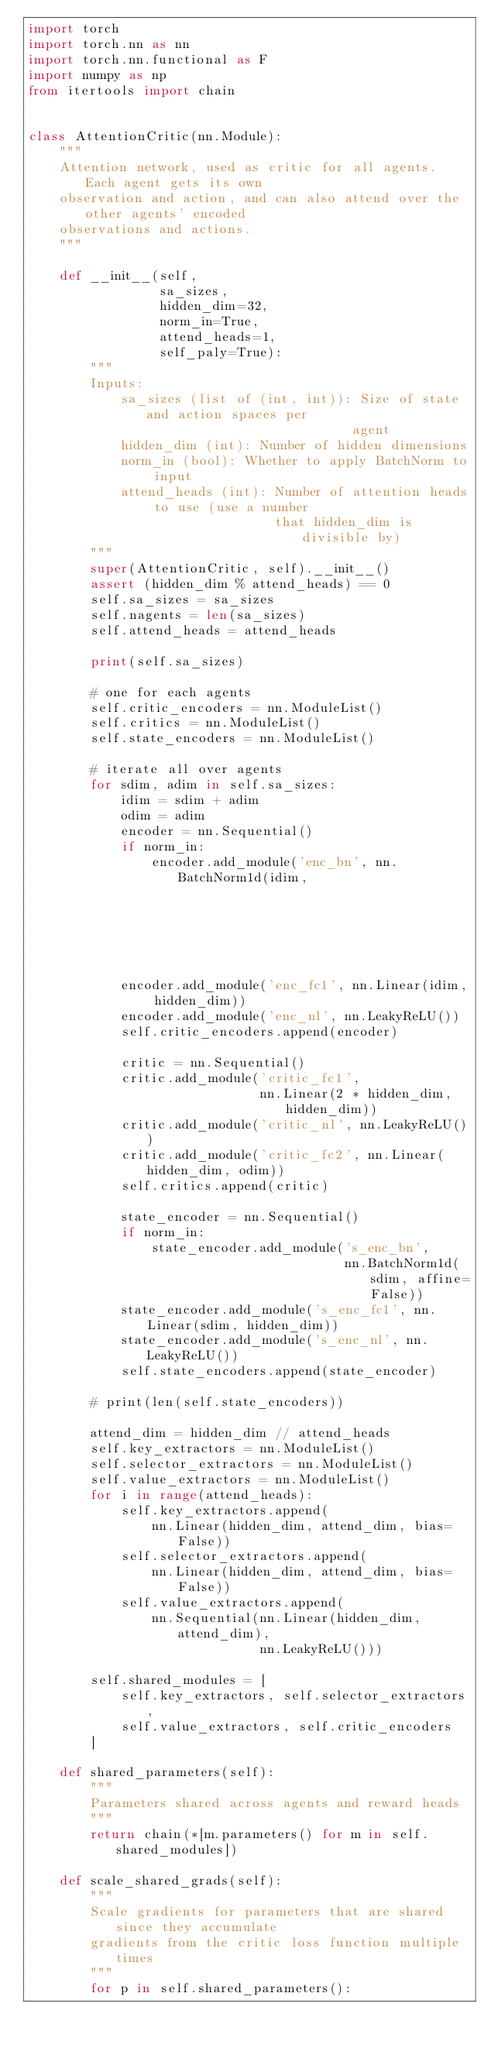<code> <loc_0><loc_0><loc_500><loc_500><_Python_>import torch
import torch.nn as nn
import torch.nn.functional as F
import numpy as np
from itertools import chain


class AttentionCritic(nn.Module):
    """
    Attention network, used as critic for all agents. Each agent gets its own
    observation and action, and can also attend over the other agents' encoded
    observations and actions.
    """

    def __init__(self,
                 sa_sizes,
                 hidden_dim=32,
                 norm_in=True,
                 attend_heads=1,
                 self_paly=True):
        """
        Inputs:
            sa_sizes (list of (int, int)): Size of state and action spaces per
                                          agent
            hidden_dim (int): Number of hidden dimensions
            norm_in (bool): Whether to apply BatchNorm to input
            attend_heads (int): Number of attention heads to use (use a number
                                that hidden_dim is divisible by)
        """
        super(AttentionCritic, self).__init__()
        assert (hidden_dim % attend_heads) == 0
        self.sa_sizes = sa_sizes
        self.nagents = len(sa_sizes)
        self.attend_heads = attend_heads

        print(self.sa_sizes)

        # one for each agents
        self.critic_encoders = nn.ModuleList()
        self.critics = nn.ModuleList()
        self.state_encoders = nn.ModuleList()

        # iterate all over agents
        for sdim, adim in self.sa_sizes:
            idim = sdim + adim
            odim = adim
            encoder = nn.Sequential()
            if norm_in:
                encoder.add_module('enc_bn', nn.BatchNorm1d(idim,
                                                            affine=False))
            encoder.add_module('enc_fc1', nn.Linear(idim, hidden_dim))
            encoder.add_module('enc_nl', nn.LeakyReLU())
            self.critic_encoders.append(encoder)

            critic = nn.Sequential()
            critic.add_module('critic_fc1',
                              nn.Linear(2 * hidden_dim, hidden_dim))
            critic.add_module('critic_nl', nn.LeakyReLU())
            critic.add_module('critic_fc2', nn.Linear(hidden_dim, odim))
            self.critics.append(critic)

            state_encoder = nn.Sequential()
            if norm_in:
                state_encoder.add_module('s_enc_bn',
                                         nn.BatchNorm1d(sdim, affine=False))
            state_encoder.add_module('s_enc_fc1', nn.Linear(sdim, hidden_dim))
            state_encoder.add_module('s_enc_nl', nn.LeakyReLU())
            self.state_encoders.append(state_encoder)

        # print(len(self.state_encoders))

        attend_dim = hidden_dim // attend_heads
        self.key_extractors = nn.ModuleList()
        self.selector_extractors = nn.ModuleList()
        self.value_extractors = nn.ModuleList()
        for i in range(attend_heads):
            self.key_extractors.append(
                nn.Linear(hidden_dim, attend_dim, bias=False))
            self.selector_extractors.append(
                nn.Linear(hidden_dim, attend_dim, bias=False))
            self.value_extractors.append(
                nn.Sequential(nn.Linear(hidden_dim, attend_dim),
                              nn.LeakyReLU()))

        self.shared_modules = [
            self.key_extractors, self.selector_extractors,
            self.value_extractors, self.critic_encoders
        ]

    def shared_parameters(self):
        """
        Parameters shared across agents and reward heads
        """
        return chain(*[m.parameters() for m in self.shared_modules])

    def scale_shared_grads(self):
        """
        Scale gradients for parameters that are shared since they accumulate
        gradients from the critic loss function multiple times
        """
        for p in self.shared_parameters():</code> 